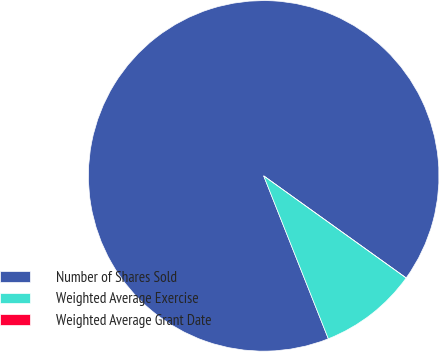<chart> <loc_0><loc_0><loc_500><loc_500><pie_chart><fcel>Number of Shares Sold<fcel>Weighted Average Exercise<fcel>Weighted Average Grant Date<nl><fcel>90.91%<fcel>9.09%<fcel>0.0%<nl></chart> 